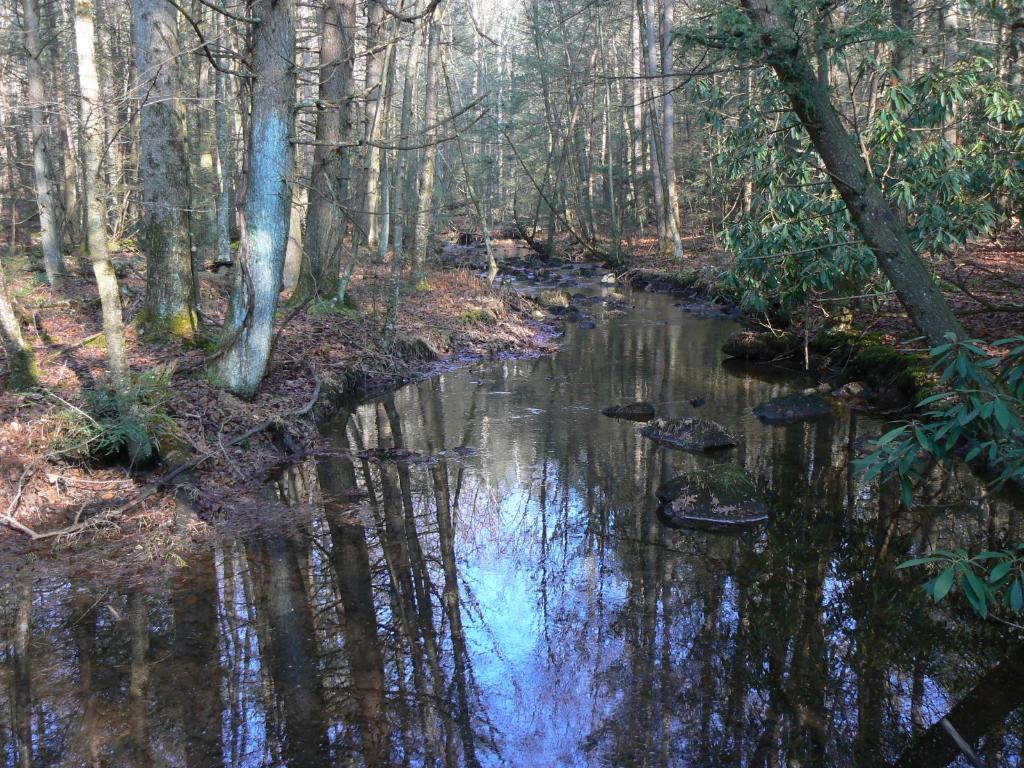What is present in the image that is not solid? There is water in the image. What type of vegetation can be seen in the image? There are trees in the image. What is the relationship between the trees and the water in the image? The reflection of trees is visible on the water. What else can be seen reflected on the water in the image? The reflection of the sky is visible on the water. Where is the pail located in the image? There is no pail present in the image. What type of bird can be seen perched on the trees in the image? There are no birds visible in the image, including owls. 